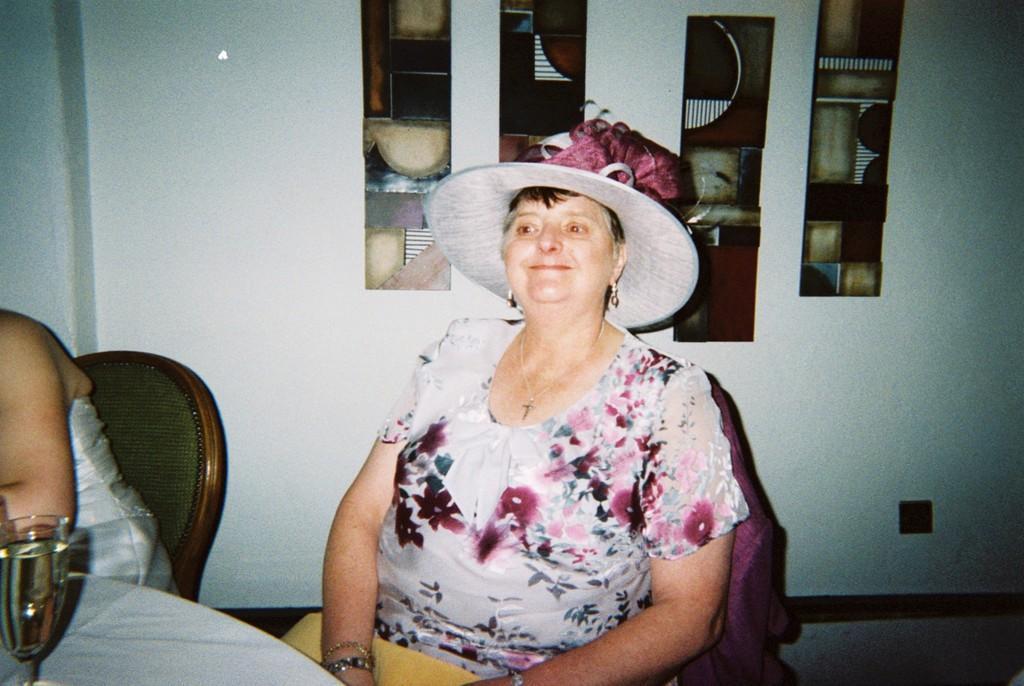In one or two sentences, can you explain what this image depicts? In this image I can see two women sitting on the chairs. I can see a glass on the table. In the background I can see some objects on the wall. 